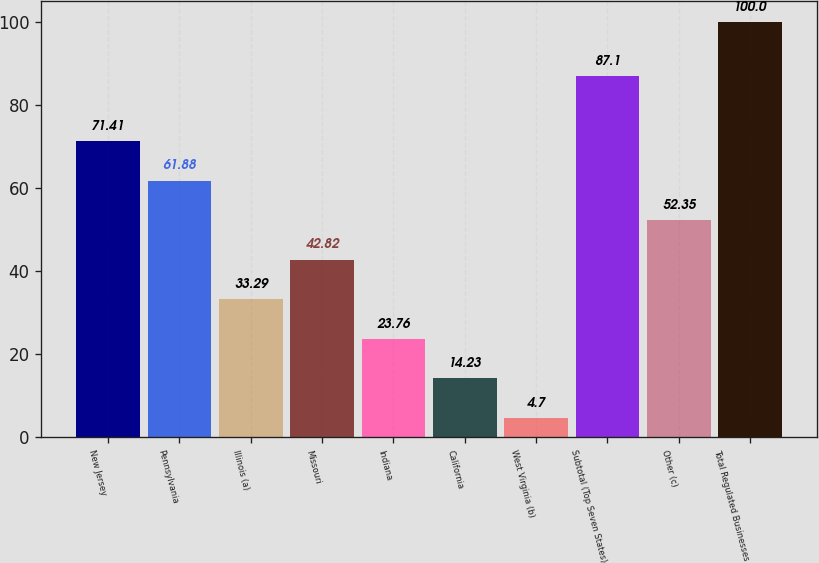<chart> <loc_0><loc_0><loc_500><loc_500><bar_chart><fcel>New Jersey<fcel>Pennsylvania<fcel>Illinois (a)<fcel>Missouri<fcel>Indiana<fcel>California<fcel>West Virginia (b)<fcel>Subtotal (Top Seven States)<fcel>Other (c)<fcel>Total Regulated Businesses<nl><fcel>71.41<fcel>61.88<fcel>33.29<fcel>42.82<fcel>23.76<fcel>14.23<fcel>4.7<fcel>87.1<fcel>52.35<fcel>100<nl></chart> 